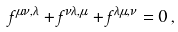<formula> <loc_0><loc_0><loc_500><loc_500>f ^ { \mu \nu , \lambda } + f ^ { \nu \lambda , \mu } + f ^ { \lambda \mu , \nu } = 0 \, ,</formula> 